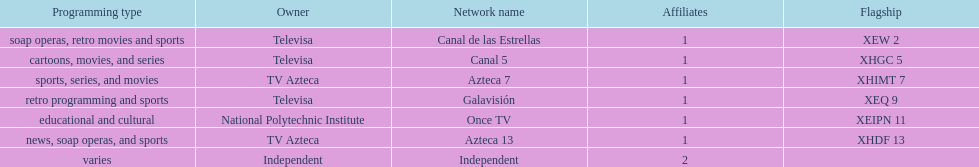Who holds ownership of azteca 7 and azteca 13? TV Azteca. 